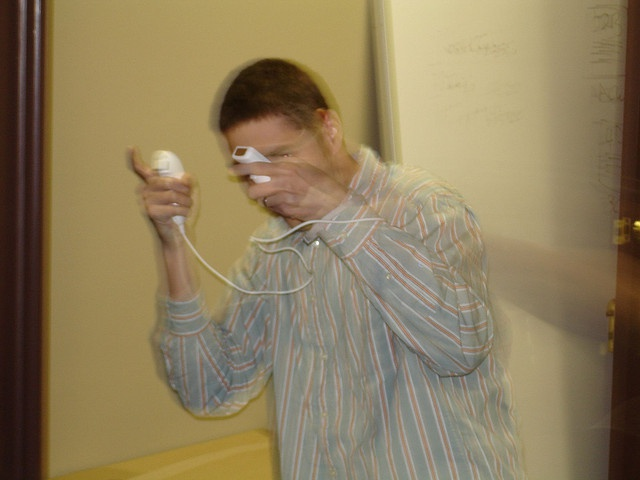Describe the objects in this image and their specific colors. I can see people in black, gray, and darkgray tones, remote in black, tan, and darkgray tones, and remote in black, darkgray, gray, and lightgray tones in this image. 